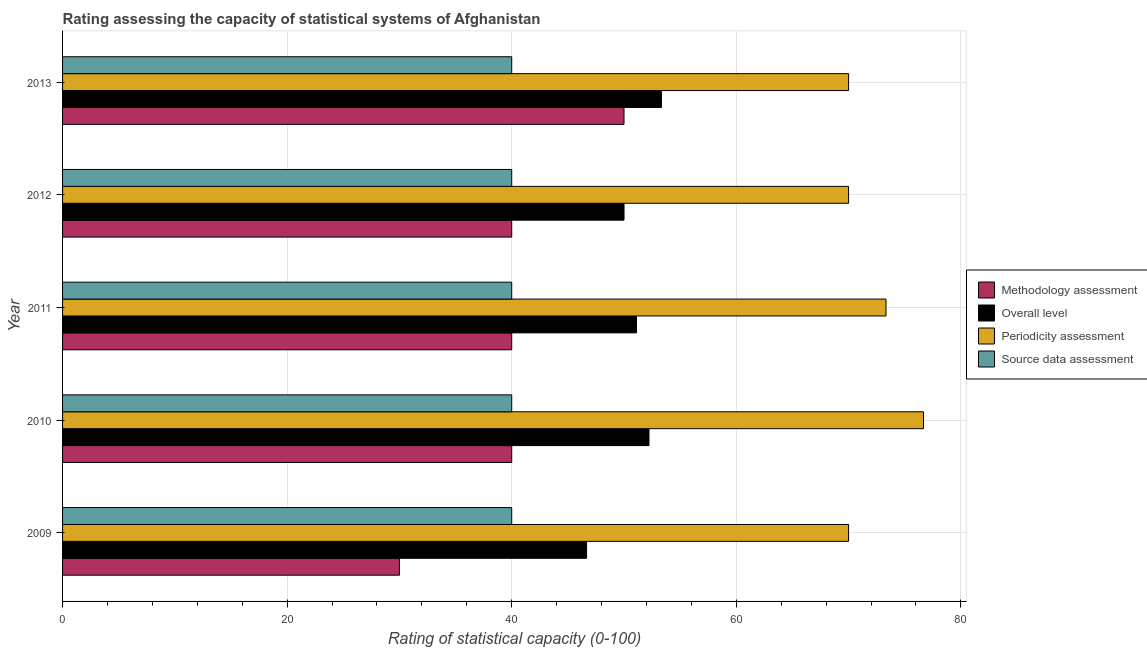Are the number of bars per tick equal to the number of legend labels?
Keep it short and to the point. Yes. What is the label of the 1st group of bars from the top?
Your answer should be compact. 2013. What is the methodology assessment rating in 2010?
Your response must be concise. 40. Across all years, what is the maximum source data assessment rating?
Offer a very short reply. 40. Across all years, what is the minimum overall level rating?
Your answer should be very brief. 46.67. What is the total periodicity assessment rating in the graph?
Your answer should be very brief. 360. What is the difference between the methodology assessment rating in 2009 and that in 2013?
Provide a succinct answer. -20. What is the difference between the source data assessment rating in 2012 and the overall level rating in 2010?
Ensure brevity in your answer.  -12.22. What is the average periodicity assessment rating per year?
Provide a succinct answer. 72. In the year 2011, what is the difference between the methodology assessment rating and source data assessment rating?
Offer a terse response. 0. In how many years, is the methodology assessment rating greater than 68 ?
Give a very brief answer. 0. What is the ratio of the periodicity assessment rating in 2011 to that in 2012?
Your response must be concise. 1.05. Is the difference between the periodicity assessment rating in 2009 and 2013 greater than the difference between the overall level rating in 2009 and 2013?
Your answer should be compact. Yes. What is the difference between the highest and the second highest overall level rating?
Provide a succinct answer. 1.11. What is the difference between the highest and the lowest periodicity assessment rating?
Keep it short and to the point. 6.67. Is it the case that in every year, the sum of the overall level rating and methodology assessment rating is greater than the sum of source data assessment rating and periodicity assessment rating?
Keep it short and to the point. No. What does the 3rd bar from the top in 2012 represents?
Offer a very short reply. Overall level. What does the 1st bar from the bottom in 2013 represents?
Provide a succinct answer. Methodology assessment. Is it the case that in every year, the sum of the methodology assessment rating and overall level rating is greater than the periodicity assessment rating?
Offer a very short reply. Yes. How many bars are there?
Your answer should be compact. 20. How many years are there in the graph?
Make the answer very short. 5. What is the difference between two consecutive major ticks on the X-axis?
Offer a terse response. 20. Does the graph contain any zero values?
Give a very brief answer. No. How are the legend labels stacked?
Your response must be concise. Vertical. What is the title of the graph?
Your answer should be compact. Rating assessing the capacity of statistical systems of Afghanistan. What is the label or title of the X-axis?
Keep it short and to the point. Rating of statistical capacity (0-100). What is the label or title of the Y-axis?
Offer a very short reply. Year. What is the Rating of statistical capacity (0-100) of Methodology assessment in 2009?
Keep it short and to the point. 30. What is the Rating of statistical capacity (0-100) of Overall level in 2009?
Keep it short and to the point. 46.67. What is the Rating of statistical capacity (0-100) in Overall level in 2010?
Offer a very short reply. 52.22. What is the Rating of statistical capacity (0-100) of Periodicity assessment in 2010?
Your response must be concise. 76.67. What is the Rating of statistical capacity (0-100) in Methodology assessment in 2011?
Offer a very short reply. 40. What is the Rating of statistical capacity (0-100) in Overall level in 2011?
Keep it short and to the point. 51.11. What is the Rating of statistical capacity (0-100) of Periodicity assessment in 2011?
Your response must be concise. 73.33. What is the Rating of statistical capacity (0-100) in Methodology assessment in 2012?
Give a very brief answer. 40. What is the Rating of statistical capacity (0-100) in Periodicity assessment in 2012?
Provide a short and direct response. 70. What is the Rating of statistical capacity (0-100) in Overall level in 2013?
Provide a short and direct response. 53.33. What is the Rating of statistical capacity (0-100) in Source data assessment in 2013?
Ensure brevity in your answer.  40. Across all years, what is the maximum Rating of statistical capacity (0-100) of Methodology assessment?
Provide a short and direct response. 50. Across all years, what is the maximum Rating of statistical capacity (0-100) in Overall level?
Provide a succinct answer. 53.33. Across all years, what is the maximum Rating of statistical capacity (0-100) in Periodicity assessment?
Keep it short and to the point. 76.67. Across all years, what is the minimum Rating of statistical capacity (0-100) of Methodology assessment?
Ensure brevity in your answer.  30. Across all years, what is the minimum Rating of statistical capacity (0-100) of Overall level?
Make the answer very short. 46.67. What is the total Rating of statistical capacity (0-100) of Methodology assessment in the graph?
Make the answer very short. 200. What is the total Rating of statistical capacity (0-100) of Overall level in the graph?
Ensure brevity in your answer.  253.33. What is the total Rating of statistical capacity (0-100) of Periodicity assessment in the graph?
Give a very brief answer. 360. What is the difference between the Rating of statistical capacity (0-100) of Overall level in 2009 and that in 2010?
Make the answer very short. -5.56. What is the difference between the Rating of statistical capacity (0-100) of Periodicity assessment in 2009 and that in 2010?
Provide a short and direct response. -6.67. What is the difference between the Rating of statistical capacity (0-100) of Source data assessment in 2009 and that in 2010?
Provide a short and direct response. 0. What is the difference between the Rating of statistical capacity (0-100) of Overall level in 2009 and that in 2011?
Your answer should be compact. -4.44. What is the difference between the Rating of statistical capacity (0-100) of Methodology assessment in 2009 and that in 2012?
Your answer should be very brief. -10. What is the difference between the Rating of statistical capacity (0-100) in Overall level in 2009 and that in 2012?
Keep it short and to the point. -3.33. What is the difference between the Rating of statistical capacity (0-100) in Periodicity assessment in 2009 and that in 2012?
Provide a short and direct response. 0. What is the difference between the Rating of statistical capacity (0-100) of Source data assessment in 2009 and that in 2012?
Your response must be concise. 0. What is the difference between the Rating of statistical capacity (0-100) of Methodology assessment in 2009 and that in 2013?
Provide a short and direct response. -20. What is the difference between the Rating of statistical capacity (0-100) in Overall level in 2009 and that in 2013?
Your answer should be compact. -6.67. What is the difference between the Rating of statistical capacity (0-100) in Periodicity assessment in 2009 and that in 2013?
Keep it short and to the point. 0. What is the difference between the Rating of statistical capacity (0-100) in Overall level in 2010 and that in 2011?
Provide a succinct answer. 1.11. What is the difference between the Rating of statistical capacity (0-100) of Periodicity assessment in 2010 and that in 2011?
Give a very brief answer. 3.33. What is the difference between the Rating of statistical capacity (0-100) in Source data assessment in 2010 and that in 2011?
Your answer should be compact. 0. What is the difference between the Rating of statistical capacity (0-100) of Overall level in 2010 and that in 2012?
Provide a short and direct response. 2.22. What is the difference between the Rating of statistical capacity (0-100) in Periodicity assessment in 2010 and that in 2012?
Your response must be concise. 6.67. What is the difference between the Rating of statistical capacity (0-100) in Source data assessment in 2010 and that in 2012?
Offer a very short reply. 0. What is the difference between the Rating of statistical capacity (0-100) in Overall level in 2010 and that in 2013?
Make the answer very short. -1.11. What is the difference between the Rating of statistical capacity (0-100) in Source data assessment in 2010 and that in 2013?
Provide a succinct answer. 0. What is the difference between the Rating of statistical capacity (0-100) of Methodology assessment in 2011 and that in 2012?
Your response must be concise. 0. What is the difference between the Rating of statistical capacity (0-100) of Periodicity assessment in 2011 and that in 2012?
Keep it short and to the point. 3.33. What is the difference between the Rating of statistical capacity (0-100) of Overall level in 2011 and that in 2013?
Offer a terse response. -2.22. What is the difference between the Rating of statistical capacity (0-100) of Source data assessment in 2011 and that in 2013?
Provide a short and direct response. 0. What is the difference between the Rating of statistical capacity (0-100) in Periodicity assessment in 2012 and that in 2013?
Make the answer very short. 0. What is the difference between the Rating of statistical capacity (0-100) of Methodology assessment in 2009 and the Rating of statistical capacity (0-100) of Overall level in 2010?
Your answer should be compact. -22.22. What is the difference between the Rating of statistical capacity (0-100) in Methodology assessment in 2009 and the Rating of statistical capacity (0-100) in Periodicity assessment in 2010?
Offer a very short reply. -46.67. What is the difference between the Rating of statistical capacity (0-100) in Overall level in 2009 and the Rating of statistical capacity (0-100) in Periodicity assessment in 2010?
Your answer should be compact. -30. What is the difference between the Rating of statistical capacity (0-100) in Overall level in 2009 and the Rating of statistical capacity (0-100) in Source data assessment in 2010?
Provide a succinct answer. 6.67. What is the difference between the Rating of statistical capacity (0-100) in Methodology assessment in 2009 and the Rating of statistical capacity (0-100) in Overall level in 2011?
Keep it short and to the point. -21.11. What is the difference between the Rating of statistical capacity (0-100) in Methodology assessment in 2009 and the Rating of statistical capacity (0-100) in Periodicity assessment in 2011?
Provide a short and direct response. -43.33. What is the difference between the Rating of statistical capacity (0-100) in Overall level in 2009 and the Rating of statistical capacity (0-100) in Periodicity assessment in 2011?
Make the answer very short. -26.67. What is the difference between the Rating of statistical capacity (0-100) in Periodicity assessment in 2009 and the Rating of statistical capacity (0-100) in Source data assessment in 2011?
Your answer should be very brief. 30. What is the difference between the Rating of statistical capacity (0-100) in Methodology assessment in 2009 and the Rating of statistical capacity (0-100) in Overall level in 2012?
Provide a short and direct response. -20. What is the difference between the Rating of statistical capacity (0-100) of Methodology assessment in 2009 and the Rating of statistical capacity (0-100) of Source data assessment in 2012?
Make the answer very short. -10. What is the difference between the Rating of statistical capacity (0-100) of Overall level in 2009 and the Rating of statistical capacity (0-100) of Periodicity assessment in 2012?
Your answer should be very brief. -23.33. What is the difference between the Rating of statistical capacity (0-100) of Methodology assessment in 2009 and the Rating of statistical capacity (0-100) of Overall level in 2013?
Your answer should be compact. -23.33. What is the difference between the Rating of statistical capacity (0-100) of Methodology assessment in 2009 and the Rating of statistical capacity (0-100) of Source data assessment in 2013?
Your response must be concise. -10. What is the difference between the Rating of statistical capacity (0-100) in Overall level in 2009 and the Rating of statistical capacity (0-100) in Periodicity assessment in 2013?
Provide a succinct answer. -23.33. What is the difference between the Rating of statistical capacity (0-100) in Methodology assessment in 2010 and the Rating of statistical capacity (0-100) in Overall level in 2011?
Your answer should be very brief. -11.11. What is the difference between the Rating of statistical capacity (0-100) of Methodology assessment in 2010 and the Rating of statistical capacity (0-100) of Periodicity assessment in 2011?
Your answer should be very brief. -33.33. What is the difference between the Rating of statistical capacity (0-100) in Methodology assessment in 2010 and the Rating of statistical capacity (0-100) in Source data assessment in 2011?
Ensure brevity in your answer.  0. What is the difference between the Rating of statistical capacity (0-100) in Overall level in 2010 and the Rating of statistical capacity (0-100) in Periodicity assessment in 2011?
Your answer should be very brief. -21.11. What is the difference between the Rating of statistical capacity (0-100) in Overall level in 2010 and the Rating of statistical capacity (0-100) in Source data assessment in 2011?
Provide a short and direct response. 12.22. What is the difference between the Rating of statistical capacity (0-100) of Periodicity assessment in 2010 and the Rating of statistical capacity (0-100) of Source data assessment in 2011?
Make the answer very short. 36.67. What is the difference between the Rating of statistical capacity (0-100) of Methodology assessment in 2010 and the Rating of statistical capacity (0-100) of Overall level in 2012?
Your response must be concise. -10. What is the difference between the Rating of statistical capacity (0-100) in Overall level in 2010 and the Rating of statistical capacity (0-100) in Periodicity assessment in 2012?
Give a very brief answer. -17.78. What is the difference between the Rating of statistical capacity (0-100) in Overall level in 2010 and the Rating of statistical capacity (0-100) in Source data assessment in 2012?
Offer a very short reply. 12.22. What is the difference between the Rating of statistical capacity (0-100) of Periodicity assessment in 2010 and the Rating of statistical capacity (0-100) of Source data assessment in 2012?
Provide a short and direct response. 36.67. What is the difference between the Rating of statistical capacity (0-100) of Methodology assessment in 2010 and the Rating of statistical capacity (0-100) of Overall level in 2013?
Keep it short and to the point. -13.33. What is the difference between the Rating of statistical capacity (0-100) in Methodology assessment in 2010 and the Rating of statistical capacity (0-100) in Periodicity assessment in 2013?
Offer a terse response. -30. What is the difference between the Rating of statistical capacity (0-100) of Methodology assessment in 2010 and the Rating of statistical capacity (0-100) of Source data assessment in 2013?
Provide a short and direct response. 0. What is the difference between the Rating of statistical capacity (0-100) of Overall level in 2010 and the Rating of statistical capacity (0-100) of Periodicity assessment in 2013?
Keep it short and to the point. -17.78. What is the difference between the Rating of statistical capacity (0-100) in Overall level in 2010 and the Rating of statistical capacity (0-100) in Source data assessment in 2013?
Ensure brevity in your answer.  12.22. What is the difference between the Rating of statistical capacity (0-100) of Periodicity assessment in 2010 and the Rating of statistical capacity (0-100) of Source data assessment in 2013?
Give a very brief answer. 36.67. What is the difference between the Rating of statistical capacity (0-100) of Methodology assessment in 2011 and the Rating of statistical capacity (0-100) of Overall level in 2012?
Make the answer very short. -10. What is the difference between the Rating of statistical capacity (0-100) in Methodology assessment in 2011 and the Rating of statistical capacity (0-100) in Source data assessment in 2012?
Offer a very short reply. 0. What is the difference between the Rating of statistical capacity (0-100) of Overall level in 2011 and the Rating of statistical capacity (0-100) of Periodicity assessment in 2012?
Your answer should be very brief. -18.89. What is the difference between the Rating of statistical capacity (0-100) in Overall level in 2011 and the Rating of statistical capacity (0-100) in Source data assessment in 2012?
Your response must be concise. 11.11. What is the difference between the Rating of statistical capacity (0-100) of Periodicity assessment in 2011 and the Rating of statistical capacity (0-100) of Source data assessment in 2012?
Your answer should be compact. 33.33. What is the difference between the Rating of statistical capacity (0-100) in Methodology assessment in 2011 and the Rating of statistical capacity (0-100) in Overall level in 2013?
Offer a very short reply. -13.33. What is the difference between the Rating of statistical capacity (0-100) in Overall level in 2011 and the Rating of statistical capacity (0-100) in Periodicity assessment in 2013?
Your answer should be very brief. -18.89. What is the difference between the Rating of statistical capacity (0-100) of Overall level in 2011 and the Rating of statistical capacity (0-100) of Source data assessment in 2013?
Give a very brief answer. 11.11. What is the difference between the Rating of statistical capacity (0-100) in Periodicity assessment in 2011 and the Rating of statistical capacity (0-100) in Source data assessment in 2013?
Make the answer very short. 33.33. What is the difference between the Rating of statistical capacity (0-100) in Methodology assessment in 2012 and the Rating of statistical capacity (0-100) in Overall level in 2013?
Your response must be concise. -13.33. What is the difference between the Rating of statistical capacity (0-100) of Methodology assessment in 2012 and the Rating of statistical capacity (0-100) of Periodicity assessment in 2013?
Offer a terse response. -30. What is the difference between the Rating of statistical capacity (0-100) in Methodology assessment in 2012 and the Rating of statistical capacity (0-100) in Source data assessment in 2013?
Your response must be concise. 0. What is the difference between the Rating of statistical capacity (0-100) in Overall level in 2012 and the Rating of statistical capacity (0-100) in Source data assessment in 2013?
Provide a short and direct response. 10. What is the average Rating of statistical capacity (0-100) in Methodology assessment per year?
Keep it short and to the point. 40. What is the average Rating of statistical capacity (0-100) in Overall level per year?
Your answer should be compact. 50.67. What is the average Rating of statistical capacity (0-100) of Periodicity assessment per year?
Ensure brevity in your answer.  72. What is the average Rating of statistical capacity (0-100) in Source data assessment per year?
Provide a succinct answer. 40. In the year 2009, what is the difference between the Rating of statistical capacity (0-100) in Methodology assessment and Rating of statistical capacity (0-100) in Overall level?
Provide a short and direct response. -16.67. In the year 2009, what is the difference between the Rating of statistical capacity (0-100) in Methodology assessment and Rating of statistical capacity (0-100) in Source data assessment?
Provide a short and direct response. -10. In the year 2009, what is the difference between the Rating of statistical capacity (0-100) in Overall level and Rating of statistical capacity (0-100) in Periodicity assessment?
Give a very brief answer. -23.33. In the year 2009, what is the difference between the Rating of statistical capacity (0-100) of Overall level and Rating of statistical capacity (0-100) of Source data assessment?
Your response must be concise. 6.67. In the year 2010, what is the difference between the Rating of statistical capacity (0-100) of Methodology assessment and Rating of statistical capacity (0-100) of Overall level?
Keep it short and to the point. -12.22. In the year 2010, what is the difference between the Rating of statistical capacity (0-100) of Methodology assessment and Rating of statistical capacity (0-100) of Periodicity assessment?
Offer a terse response. -36.67. In the year 2010, what is the difference between the Rating of statistical capacity (0-100) of Methodology assessment and Rating of statistical capacity (0-100) of Source data assessment?
Provide a succinct answer. 0. In the year 2010, what is the difference between the Rating of statistical capacity (0-100) in Overall level and Rating of statistical capacity (0-100) in Periodicity assessment?
Your answer should be very brief. -24.44. In the year 2010, what is the difference between the Rating of statistical capacity (0-100) in Overall level and Rating of statistical capacity (0-100) in Source data assessment?
Your answer should be very brief. 12.22. In the year 2010, what is the difference between the Rating of statistical capacity (0-100) of Periodicity assessment and Rating of statistical capacity (0-100) of Source data assessment?
Give a very brief answer. 36.67. In the year 2011, what is the difference between the Rating of statistical capacity (0-100) in Methodology assessment and Rating of statistical capacity (0-100) in Overall level?
Your response must be concise. -11.11. In the year 2011, what is the difference between the Rating of statistical capacity (0-100) in Methodology assessment and Rating of statistical capacity (0-100) in Periodicity assessment?
Provide a short and direct response. -33.33. In the year 2011, what is the difference between the Rating of statistical capacity (0-100) in Methodology assessment and Rating of statistical capacity (0-100) in Source data assessment?
Your answer should be compact. 0. In the year 2011, what is the difference between the Rating of statistical capacity (0-100) of Overall level and Rating of statistical capacity (0-100) of Periodicity assessment?
Offer a very short reply. -22.22. In the year 2011, what is the difference between the Rating of statistical capacity (0-100) of Overall level and Rating of statistical capacity (0-100) of Source data assessment?
Keep it short and to the point. 11.11. In the year 2011, what is the difference between the Rating of statistical capacity (0-100) of Periodicity assessment and Rating of statistical capacity (0-100) of Source data assessment?
Offer a terse response. 33.33. In the year 2012, what is the difference between the Rating of statistical capacity (0-100) of Methodology assessment and Rating of statistical capacity (0-100) of Overall level?
Offer a very short reply. -10. In the year 2012, what is the difference between the Rating of statistical capacity (0-100) in Methodology assessment and Rating of statistical capacity (0-100) in Periodicity assessment?
Provide a short and direct response. -30. In the year 2012, what is the difference between the Rating of statistical capacity (0-100) of Overall level and Rating of statistical capacity (0-100) of Periodicity assessment?
Ensure brevity in your answer.  -20. In the year 2012, what is the difference between the Rating of statistical capacity (0-100) of Overall level and Rating of statistical capacity (0-100) of Source data assessment?
Your answer should be compact. 10. In the year 2012, what is the difference between the Rating of statistical capacity (0-100) of Periodicity assessment and Rating of statistical capacity (0-100) of Source data assessment?
Provide a short and direct response. 30. In the year 2013, what is the difference between the Rating of statistical capacity (0-100) in Overall level and Rating of statistical capacity (0-100) in Periodicity assessment?
Keep it short and to the point. -16.67. In the year 2013, what is the difference between the Rating of statistical capacity (0-100) of Overall level and Rating of statistical capacity (0-100) of Source data assessment?
Your answer should be compact. 13.33. In the year 2013, what is the difference between the Rating of statistical capacity (0-100) of Periodicity assessment and Rating of statistical capacity (0-100) of Source data assessment?
Offer a very short reply. 30. What is the ratio of the Rating of statistical capacity (0-100) of Overall level in 2009 to that in 2010?
Provide a short and direct response. 0.89. What is the ratio of the Rating of statistical capacity (0-100) of Periodicity assessment in 2009 to that in 2010?
Give a very brief answer. 0.91. What is the ratio of the Rating of statistical capacity (0-100) in Overall level in 2009 to that in 2011?
Offer a terse response. 0.91. What is the ratio of the Rating of statistical capacity (0-100) of Periodicity assessment in 2009 to that in 2011?
Offer a very short reply. 0.95. What is the ratio of the Rating of statistical capacity (0-100) of Source data assessment in 2009 to that in 2011?
Make the answer very short. 1. What is the ratio of the Rating of statistical capacity (0-100) in Overall level in 2009 to that in 2012?
Provide a short and direct response. 0.93. What is the ratio of the Rating of statistical capacity (0-100) in Methodology assessment in 2009 to that in 2013?
Give a very brief answer. 0.6. What is the ratio of the Rating of statistical capacity (0-100) of Source data assessment in 2009 to that in 2013?
Offer a terse response. 1. What is the ratio of the Rating of statistical capacity (0-100) of Methodology assessment in 2010 to that in 2011?
Offer a terse response. 1. What is the ratio of the Rating of statistical capacity (0-100) of Overall level in 2010 to that in 2011?
Ensure brevity in your answer.  1.02. What is the ratio of the Rating of statistical capacity (0-100) in Periodicity assessment in 2010 to that in 2011?
Give a very brief answer. 1.05. What is the ratio of the Rating of statistical capacity (0-100) in Source data assessment in 2010 to that in 2011?
Ensure brevity in your answer.  1. What is the ratio of the Rating of statistical capacity (0-100) of Methodology assessment in 2010 to that in 2012?
Offer a terse response. 1. What is the ratio of the Rating of statistical capacity (0-100) in Overall level in 2010 to that in 2012?
Give a very brief answer. 1.04. What is the ratio of the Rating of statistical capacity (0-100) of Periodicity assessment in 2010 to that in 2012?
Your answer should be very brief. 1.1. What is the ratio of the Rating of statistical capacity (0-100) in Source data assessment in 2010 to that in 2012?
Make the answer very short. 1. What is the ratio of the Rating of statistical capacity (0-100) of Methodology assessment in 2010 to that in 2013?
Make the answer very short. 0.8. What is the ratio of the Rating of statistical capacity (0-100) of Overall level in 2010 to that in 2013?
Offer a terse response. 0.98. What is the ratio of the Rating of statistical capacity (0-100) in Periodicity assessment in 2010 to that in 2013?
Your answer should be very brief. 1.1. What is the ratio of the Rating of statistical capacity (0-100) in Source data assessment in 2010 to that in 2013?
Your answer should be very brief. 1. What is the ratio of the Rating of statistical capacity (0-100) of Overall level in 2011 to that in 2012?
Provide a succinct answer. 1.02. What is the ratio of the Rating of statistical capacity (0-100) in Periodicity assessment in 2011 to that in 2012?
Your answer should be very brief. 1.05. What is the ratio of the Rating of statistical capacity (0-100) in Source data assessment in 2011 to that in 2012?
Provide a succinct answer. 1. What is the ratio of the Rating of statistical capacity (0-100) of Methodology assessment in 2011 to that in 2013?
Make the answer very short. 0.8. What is the ratio of the Rating of statistical capacity (0-100) of Periodicity assessment in 2011 to that in 2013?
Ensure brevity in your answer.  1.05. What is the ratio of the Rating of statistical capacity (0-100) in Periodicity assessment in 2012 to that in 2013?
Offer a very short reply. 1. What is the ratio of the Rating of statistical capacity (0-100) of Source data assessment in 2012 to that in 2013?
Provide a succinct answer. 1. What is the difference between the highest and the second highest Rating of statistical capacity (0-100) in Methodology assessment?
Provide a succinct answer. 10. What is the difference between the highest and the lowest Rating of statistical capacity (0-100) in Methodology assessment?
Your answer should be very brief. 20. What is the difference between the highest and the lowest Rating of statistical capacity (0-100) of Source data assessment?
Give a very brief answer. 0. 